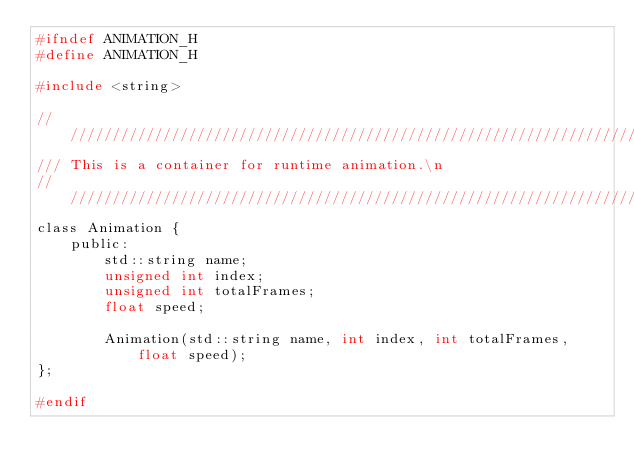<code> <loc_0><loc_0><loc_500><loc_500><_C_>#ifndef ANIMATION_H
#define ANIMATION_H

#include <string>

//////////////////////////////////////////////////////////////////////////////////////////////////
/// This is a container for runtime animation.\n
//////////////////////////////////////////////////////////////////////////////////////////////////
class Animation {
    public:
        std::string name;
        unsigned int index;
        unsigned int totalFrames;
        float speed;

        Animation(std::string name, int index, int totalFrames, float speed);
};

#endif</code> 